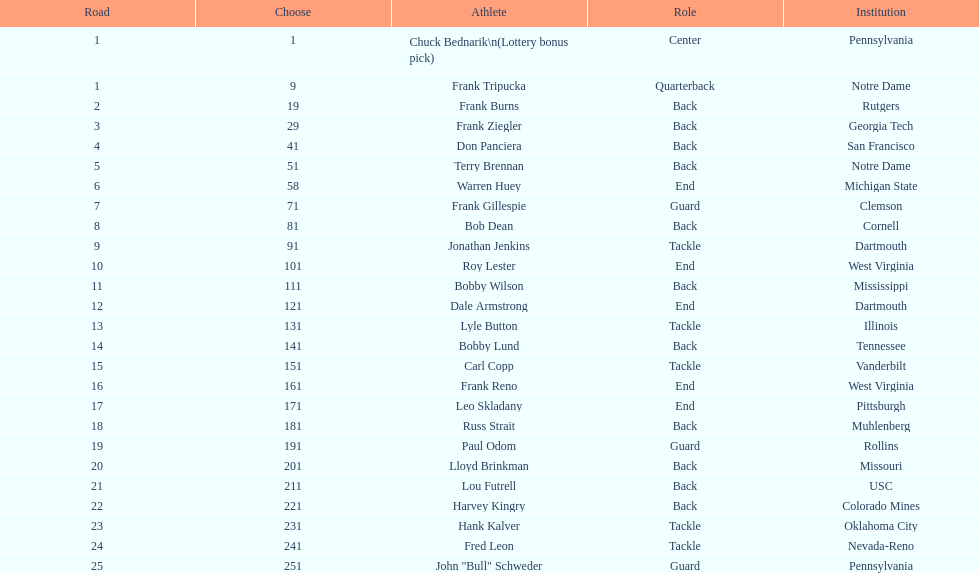How many draft picks were between frank tripucka and dale armstrong? 10. 